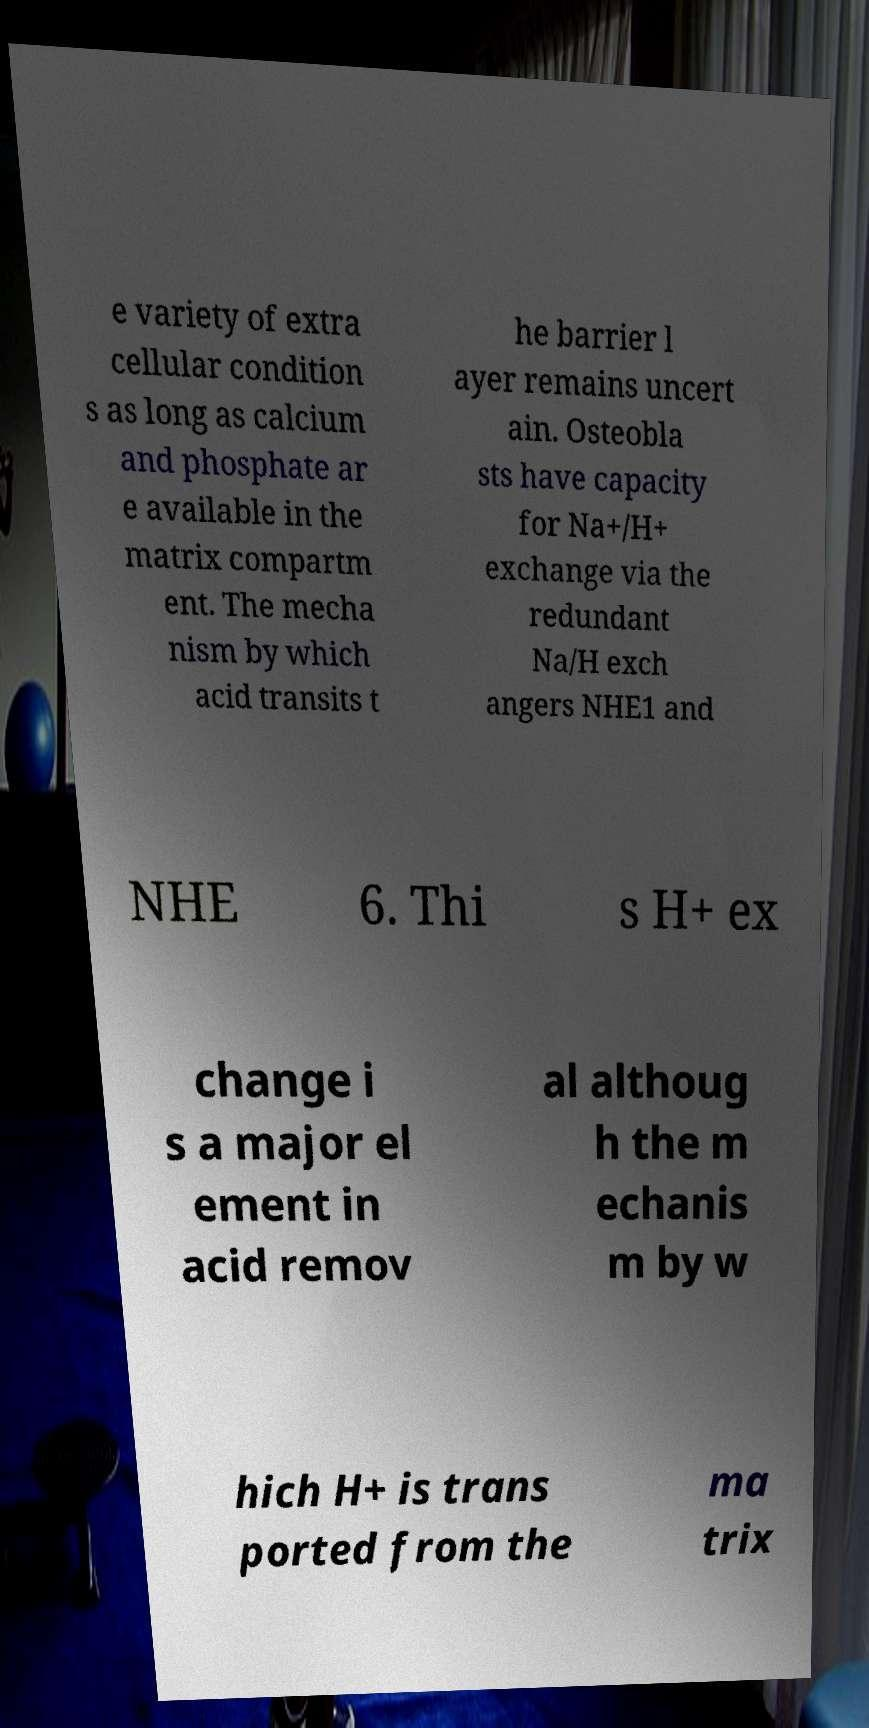What messages or text are displayed in this image? I need them in a readable, typed format. e variety of extra cellular condition s as long as calcium and phosphate ar e available in the matrix compartm ent. The mecha nism by which acid transits t he barrier l ayer remains uncert ain. Osteobla sts have capacity for Na+/H+ exchange via the redundant Na/H exch angers NHE1 and NHE 6. Thi s H+ ex change i s a major el ement in acid remov al althoug h the m echanis m by w hich H+ is trans ported from the ma trix 